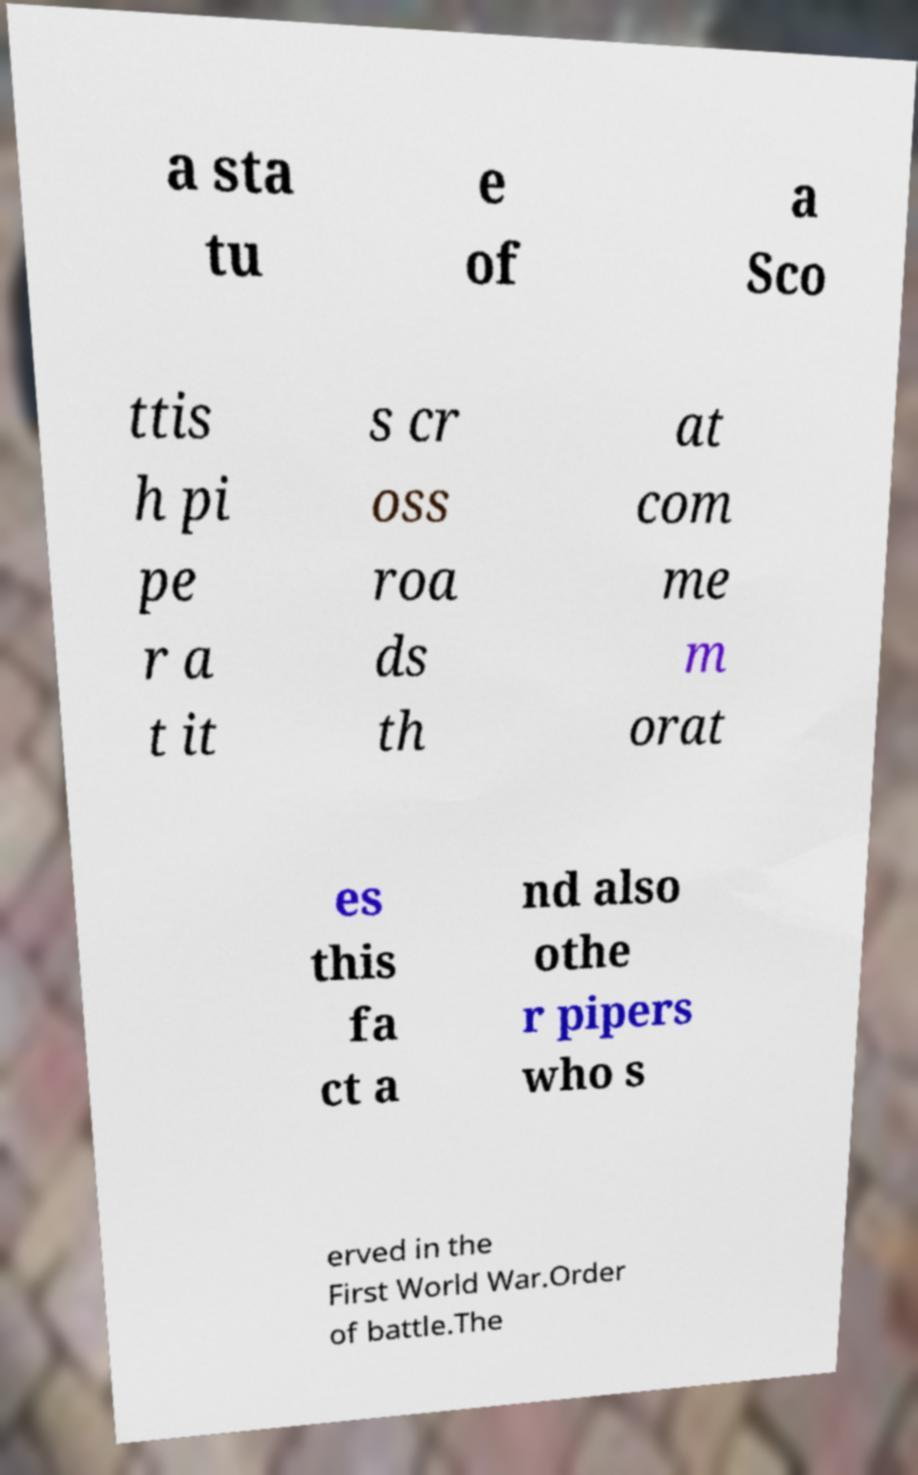Could you assist in decoding the text presented in this image and type it out clearly? a sta tu e of a Sco ttis h pi pe r a t it s cr oss roa ds th at com me m orat es this fa ct a nd also othe r pipers who s erved in the First World War.Order of battle.The 